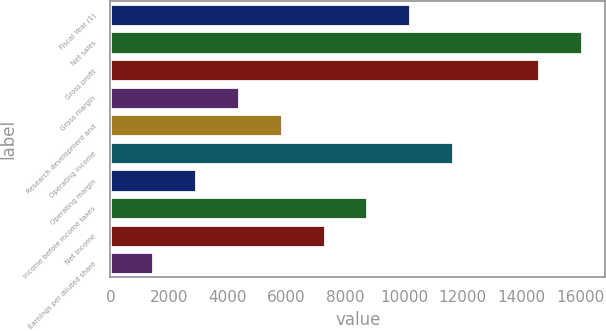<chart> <loc_0><loc_0><loc_500><loc_500><bar_chart><fcel>Fiscal Year (1)<fcel>Net sales<fcel>Gross profit<fcel>Gross margin<fcel>Research development and<fcel>Operating income<fcel>Operating margin<fcel>Income before income taxes<fcel>Net income<fcel>Earnings per diluted share<nl><fcel>10211.7<fcel>16046.8<fcel>14588<fcel>4376.68<fcel>5835.44<fcel>11670.5<fcel>2917.92<fcel>8752.96<fcel>7294.2<fcel>1459.16<nl></chart> 